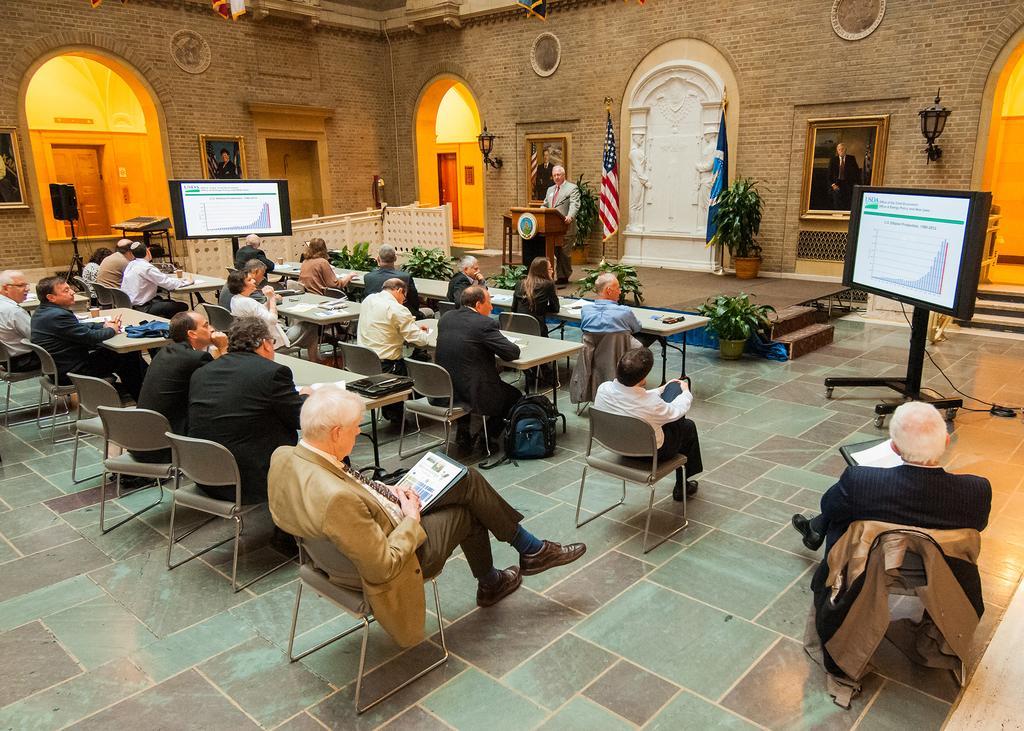How would you summarize this image in a sentence or two? In this picture we can see a man standing at podium and talking and in front of him we can see people sitting on chair and listening to him an aside to them we have screens, speakers and in background we can see fence, wall, arch, light, flags, frames, flower pot with plant in it. 